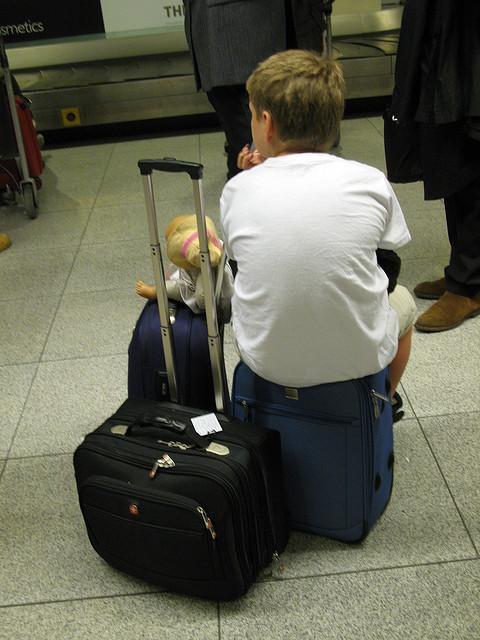How many suitcases can be seen?
Give a very brief answer. 3. How many people are there?
Give a very brief answer. 3. 